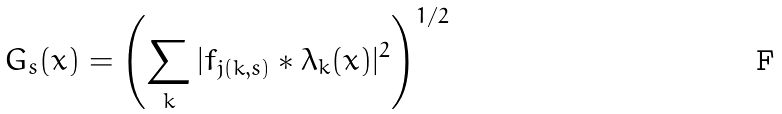Convert formula to latex. <formula><loc_0><loc_0><loc_500><loc_500>G _ { s } ( x ) = \left ( \sum _ { k } | f _ { j ( k , s ) } * \lambda _ { k } ( x ) | ^ { 2 } \right ) ^ { 1 / 2 }</formula> 